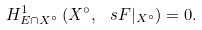Convert formula to latex. <formula><loc_0><loc_0><loc_500><loc_500>H ^ { 1 } _ { E \cap X ^ { \circ } } \left ( X ^ { \circ } , \, \ s F | _ { X ^ { \circ } } \right ) = 0 .</formula> 